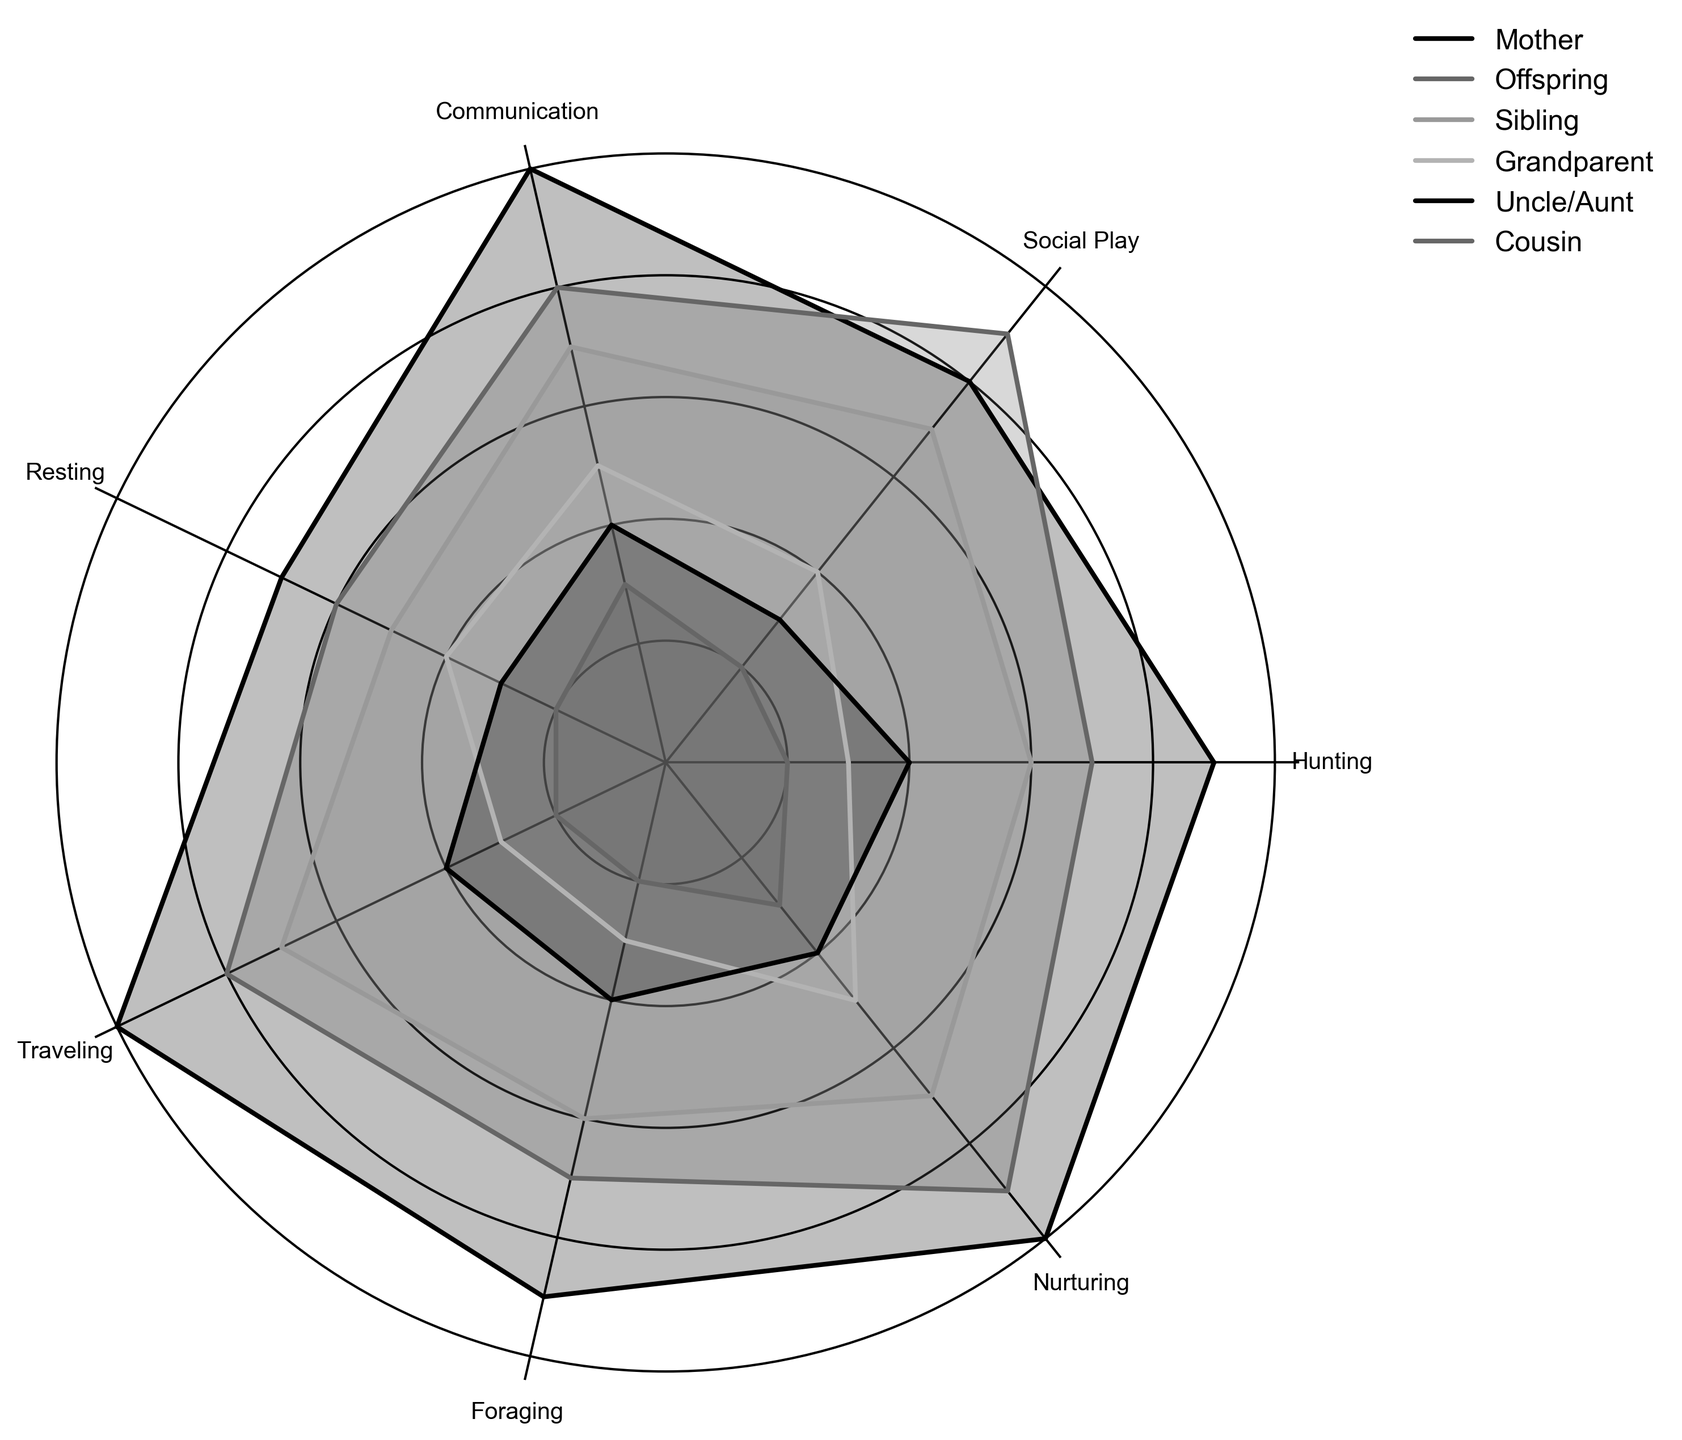Which relation type shows the highest level of nurturing interaction? The radar chart's filled areas and lines for each relationship type make it visually clear that 'Mother' has a point at a nurturing level of 10, which is the highest.
Answer: Mother Among siblings, which activity has the lowest level of interaction? By looking at the plot, we can observe that for the 'Sibling' line, the activity with the lowest point (closest to the center) is 'Resting', with a score of 5.
Answer: Resting Compare the social play interactions between offspring and uncles/aunts. Which group shows higher interaction? The radar chart shows both 'Offspring' and 'Uncle/Aunt' lines for social play. The 'Offspring' line reaches a value of 9, while 'Uncle/Aunt' reaches a value of 3, indicating 'Offspring' has higher interaction.
Answer: Offspring Which category shows equal interaction levels between hunting for mothers and traveling for offspring? The radar chart indicates that both hunting for mothers and traveling for offspring reach a value of 9.
Answer: Hunting for mothers and traveling for offspring What is the average level of interaction for siblings in the travel, hunting, and foraging activities? For 'Siblings', the levels are 7 for traveling, 6 for hunting, and 6 for foraging. The average is calculated as (7+6+6)/3 = 19/3 = 6.33.
Answer: 6.33 What are the dominant activities for grandparents concerning social interactions? The radar chart shows that for 'Grandparent', the highest points are at 'Communication' (5) and 'Nurturing' (5), both being the dominant activities compared to other interactions for 'Grandparent.'
Answer: Communication and Nurturing Between mothers and cousins, who has a higher foraging interaction level, and by how much? The radar chart shows 'Mother' has a foraging level of 9, while 'Cousin' has a level of 2. The difference being 9 - 2 = 7.
Answer: Mother by 7 Which relationship type has the most balanced interaction levels across all categories? A balanced interaction level means the points are roughly equidistant from the center on the radar chart. 'Offspring' appears to have values within the 6-9 range for all categories, showing the most balance.
Answer: Offspring Which activity shows the greatest difference in the levels of interaction between mothers and aunts/uncles? The radar chart indicates that 'Traveling' shows a value of 10 for mothers and 4 for uncles/aunts, a difference of 6, which is the greatest compared to other activities.
Answer: Traveling 